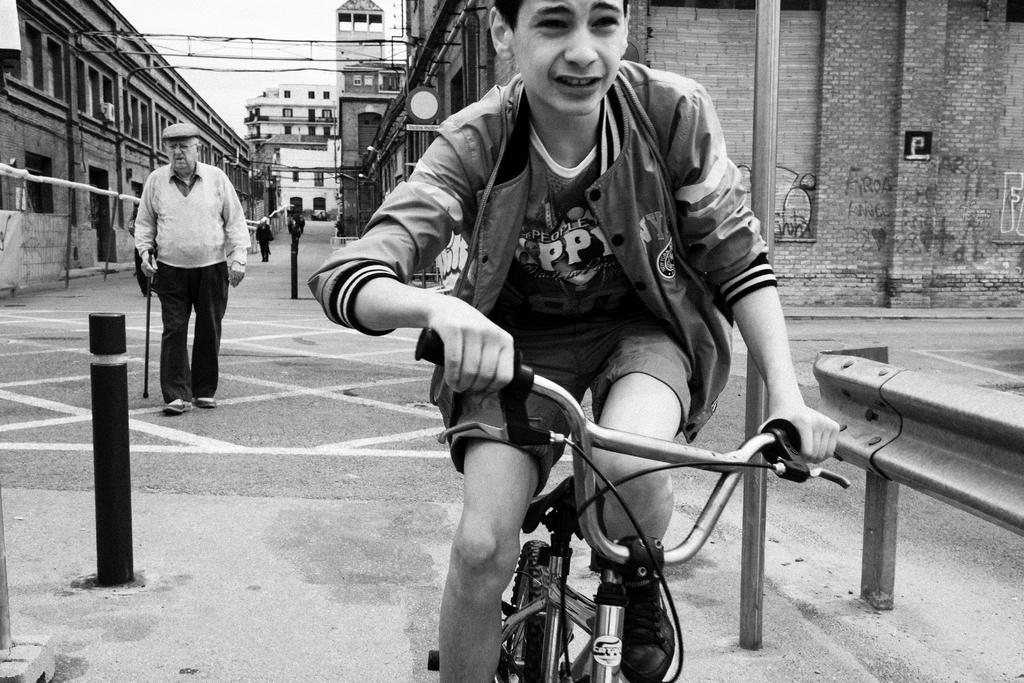Who is the main subject in the image? The main subject in the image is a boy. What is the boy doing in the image? The boy is on a cycle in the image. Who else is present in the image? There is also a man in the image. What is the man doing in the image? The man is on a path in the image. What can be seen in the background of the image? There are buildings in the background of the image. Are there any other people visible in the image? Yes, there is a person in the background of the image. What type of insurance policy is the boy considering in the image? There is no indication in the image that the boy is considering any insurance policy. What store is the man entering in the image? There is no store present in the image; the man is walking on a path. 